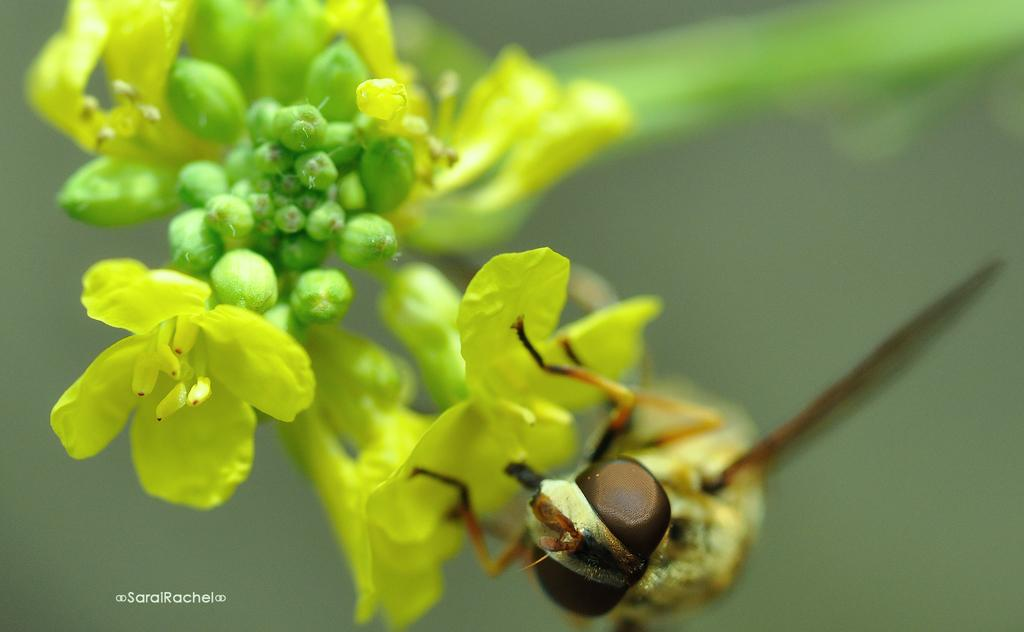What is the main subject of the image? There is an insect on a flower in the image. What is the stage of the other flowers in the image? There are buds visible in the image. Can you describe the background of the image? The background of the image is not clear. Is there any text present in the image? Yes, there is text in the bottom left corner of the image. What type of attraction can be seen in the image? There is no attraction present in the image; it features an insect on a flower and buds. Can you tell me how many forks are visible in the image? There are no forks present in the image. 